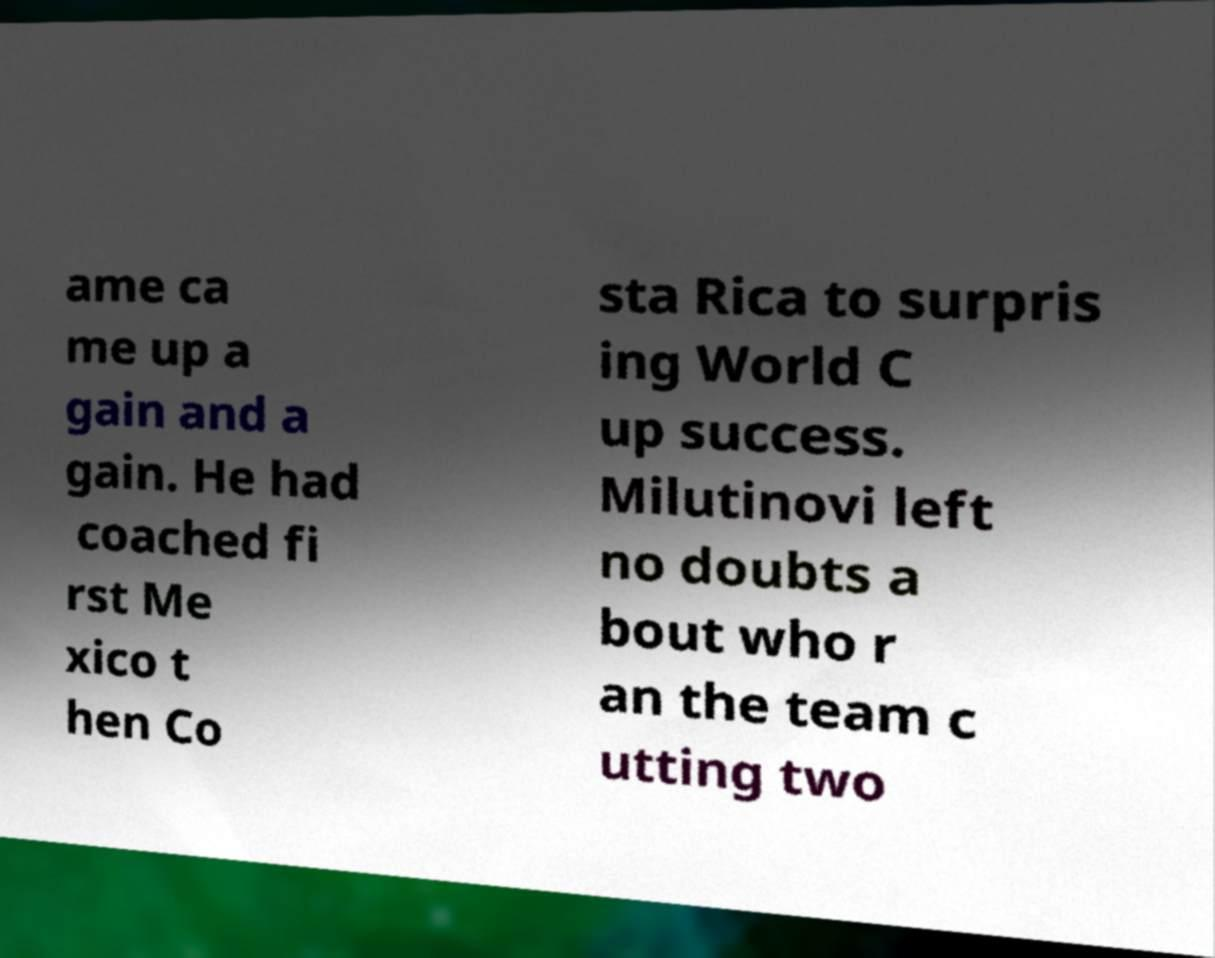Please identify and transcribe the text found in this image. ame ca me up a gain and a gain. He had coached fi rst Me xico t hen Co sta Rica to surpris ing World C up success. Milutinovi left no doubts a bout who r an the team c utting two 